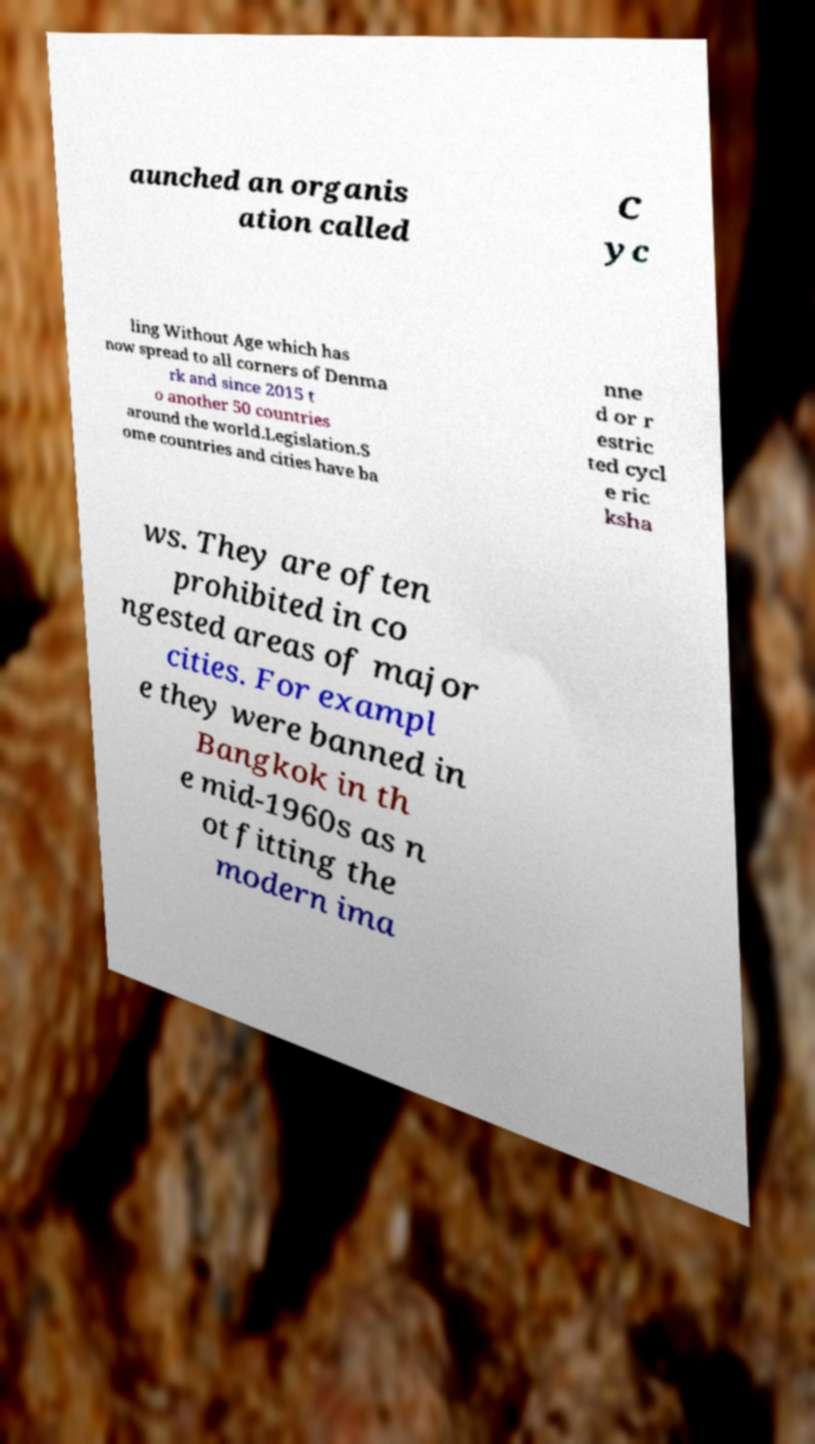For documentation purposes, I need the text within this image transcribed. Could you provide that? aunched an organis ation called C yc ling Without Age which has now spread to all corners of Denma rk and since 2015 t o another 50 countries around the world.Legislation.S ome countries and cities have ba nne d or r estric ted cycl e ric ksha ws. They are often prohibited in co ngested areas of major cities. For exampl e they were banned in Bangkok in th e mid-1960s as n ot fitting the modern ima 